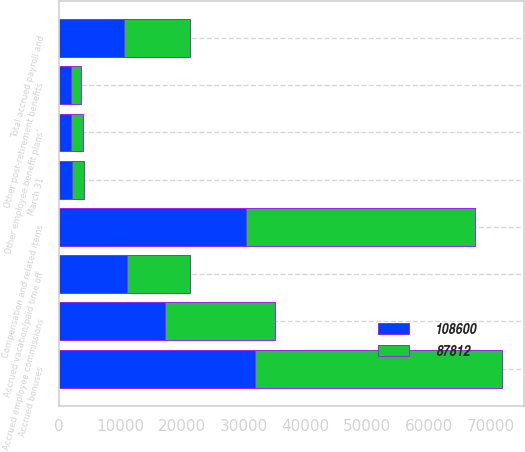Convert chart to OTSL. <chart><loc_0><loc_0><loc_500><loc_500><stacked_bar_chart><ecel><fcel>March 31<fcel>Compensation and related items<fcel>Accrued vacation/paid time off<fcel>Accrued bonuses<fcel>Accrued employee commissions<fcel>Other post-retirement benefits<fcel>Other employee benefit plans'<fcel>Total accrued payroll and<nl><fcel>87812<fcel>2019<fcel>37251<fcel>10191<fcel>40194<fcel>17854<fcel>1633<fcel>1935<fcel>10601<nl><fcel>108600<fcel>2018<fcel>30270<fcel>11011<fcel>31716<fcel>17168<fcel>1906<fcel>1929<fcel>10601<nl></chart> 